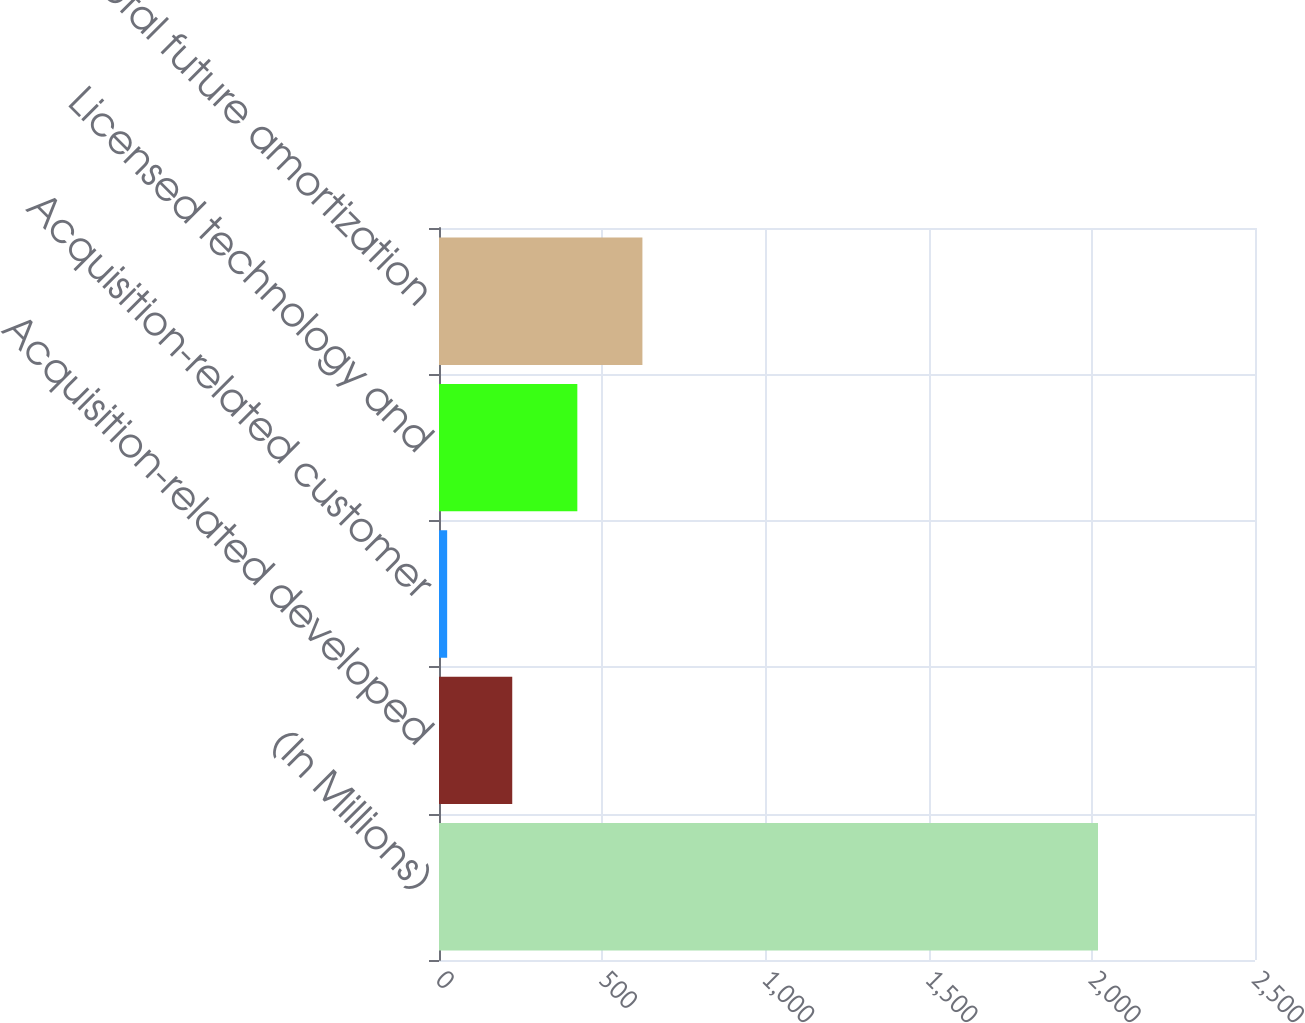Convert chart. <chart><loc_0><loc_0><loc_500><loc_500><bar_chart><fcel>(In Millions)<fcel>Acquisition-related developed<fcel>Acquisition-related customer<fcel>Licensed technology and<fcel>Total future amortization<nl><fcel>2019<fcel>224.4<fcel>25<fcel>423.8<fcel>623.2<nl></chart> 